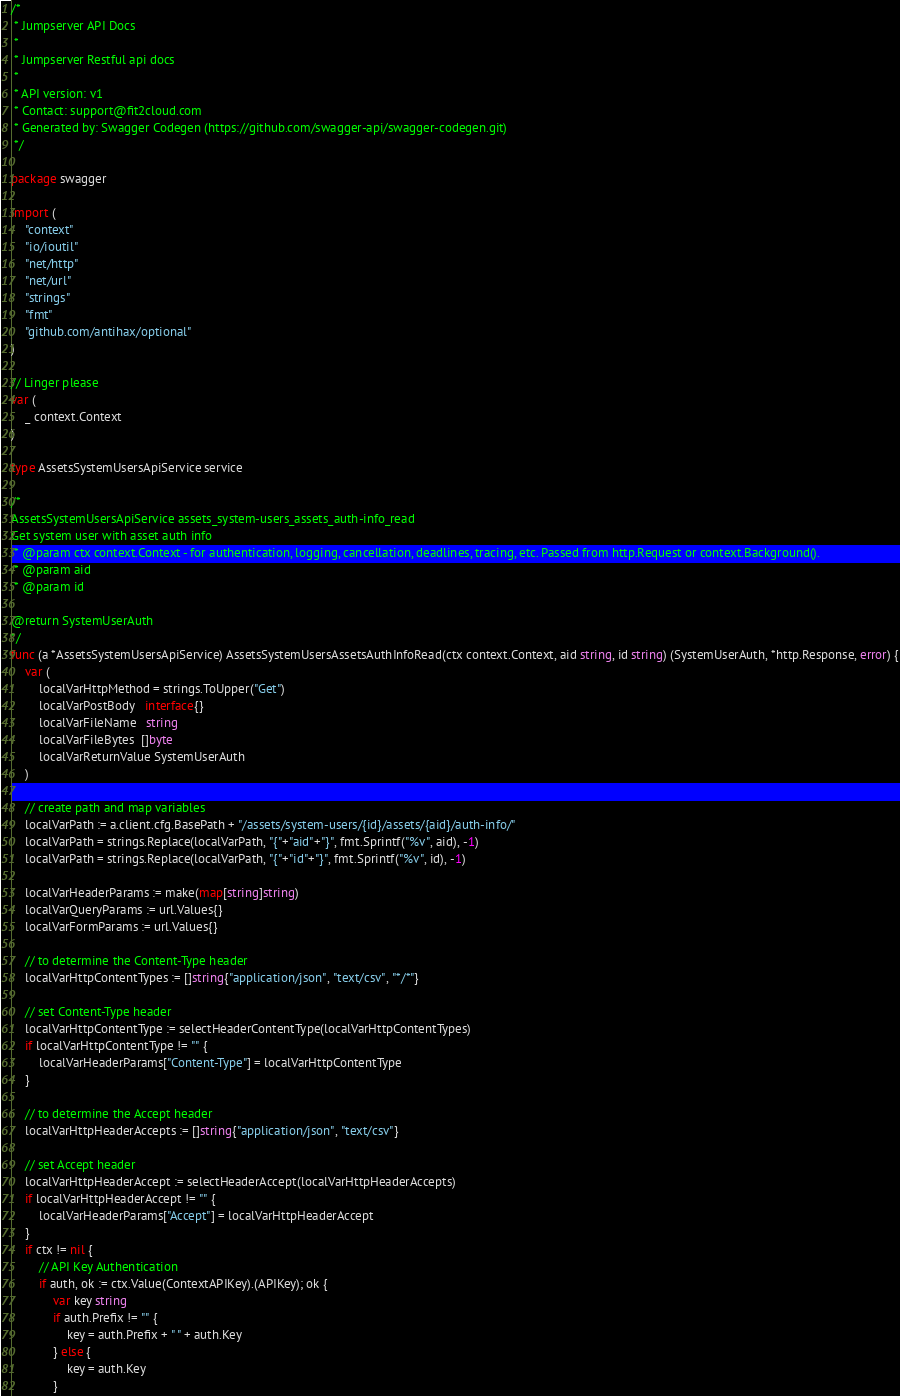Convert code to text. <code><loc_0><loc_0><loc_500><loc_500><_Go_>/*
 * Jumpserver API Docs
 *
 * Jumpserver Restful api docs
 *
 * API version: v1
 * Contact: support@fit2cloud.com
 * Generated by: Swagger Codegen (https://github.com/swagger-api/swagger-codegen.git)
 */

package swagger

import (
	"context"
	"io/ioutil"
	"net/http"
	"net/url"
	"strings"
	"fmt"
	"github.com/antihax/optional"
)

// Linger please
var (
	_ context.Context
)

type AssetsSystemUsersApiService service

/* 
AssetsSystemUsersApiService assets_system-users_assets_auth-info_read
Get system user with asset auth info
 * @param ctx context.Context - for authentication, logging, cancellation, deadlines, tracing, etc. Passed from http.Request or context.Background().
 * @param aid
 * @param id

@return SystemUserAuth
*/
func (a *AssetsSystemUsersApiService) AssetsSystemUsersAssetsAuthInfoRead(ctx context.Context, aid string, id string) (SystemUserAuth, *http.Response, error) {
	var (
		localVarHttpMethod = strings.ToUpper("Get")
		localVarPostBody   interface{}
		localVarFileName   string
		localVarFileBytes  []byte
		localVarReturnValue SystemUserAuth
	)

	// create path and map variables
	localVarPath := a.client.cfg.BasePath + "/assets/system-users/{id}/assets/{aid}/auth-info/"
	localVarPath = strings.Replace(localVarPath, "{"+"aid"+"}", fmt.Sprintf("%v", aid), -1)
	localVarPath = strings.Replace(localVarPath, "{"+"id"+"}", fmt.Sprintf("%v", id), -1)

	localVarHeaderParams := make(map[string]string)
	localVarQueryParams := url.Values{}
	localVarFormParams := url.Values{}

	// to determine the Content-Type header
	localVarHttpContentTypes := []string{"application/json", "text/csv", "*/*"}

	// set Content-Type header
	localVarHttpContentType := selectHeaderContentType(localVarHttpContentTypes)
	if localVarHttpContentType != "" {
		localVarHeaderParams["Content-Type"] = localVarHttpContentType
	}

	// to determine the Accept header
	localVarHttpHeaderAccepts := []string{"application/json", "text/csv"}

	// set Accept header
	localVarHttpHeaderAccept := selectHeaderAccept(localVarHttpHeaderAccepts)
	if localVarHttpHeaderAccept != "" {
		localVarHeaderParams["Accept"] = localVarHttpHeaderAccept
	}
	if ctx != nil {
		// API Key Authentication
		if auth, ok := ctx.Value(ContextAPIKey).(APIKey); ok {
			var key string
			if auth.Prefix != "" {
				key = auth.Prefix + " " + auth.Key
			} else {
				key = auth.Key
			}</code> 